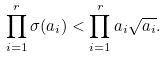<formula> <loc_0><loc_0><loc_500><loc_500>\prod _ { i = 1 } ^ { r } \sigma ( a _ { i } ) < \prod _ { i = 1 } ^ { r } a _ { i } \sqrt { a _ { i } } .</formula> 